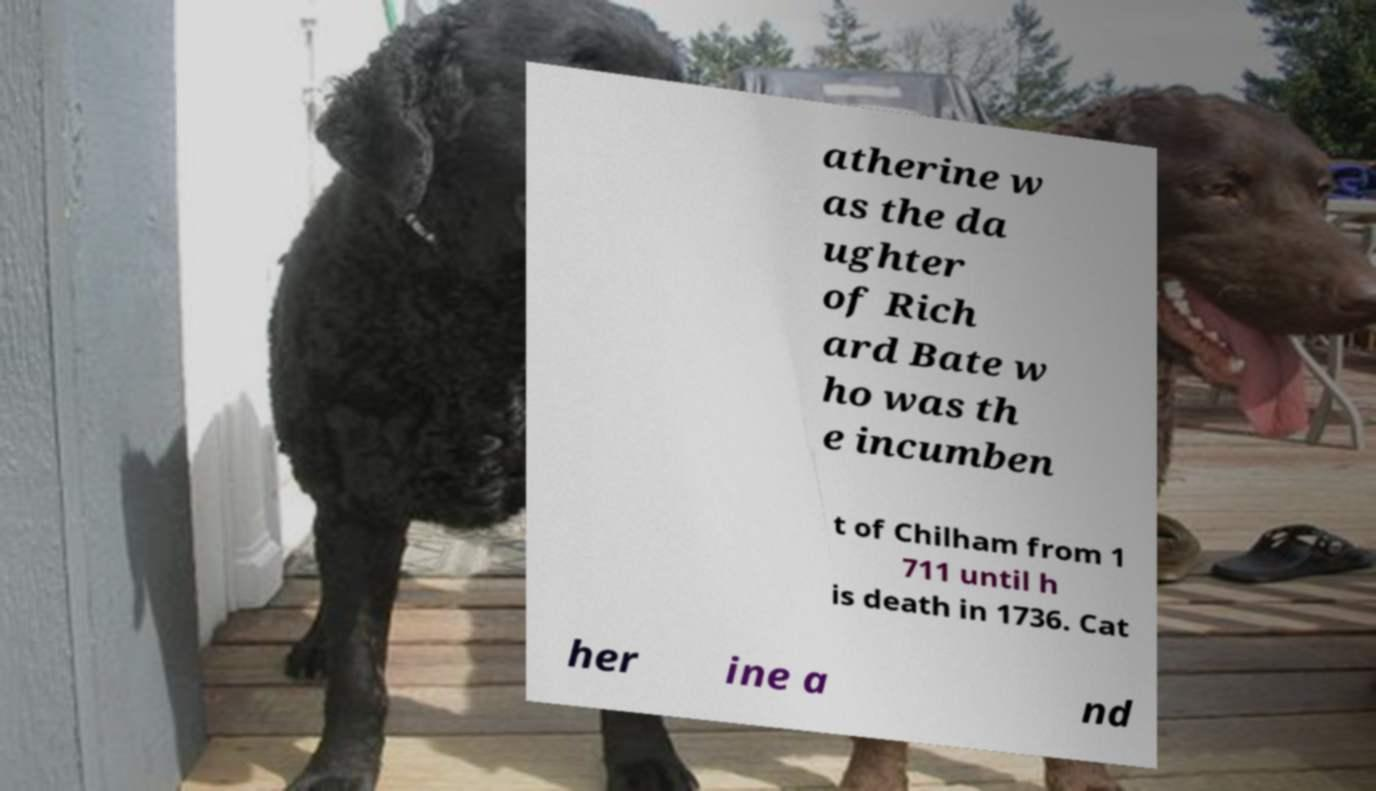Could you assist in decoding the text presented in this image and type it out clearly? atherine w as the da ughter of Rich ard Bate w ho was th e incumben t of Chilham from 1 711 until h is death in 1736. Cat her ine a nd 